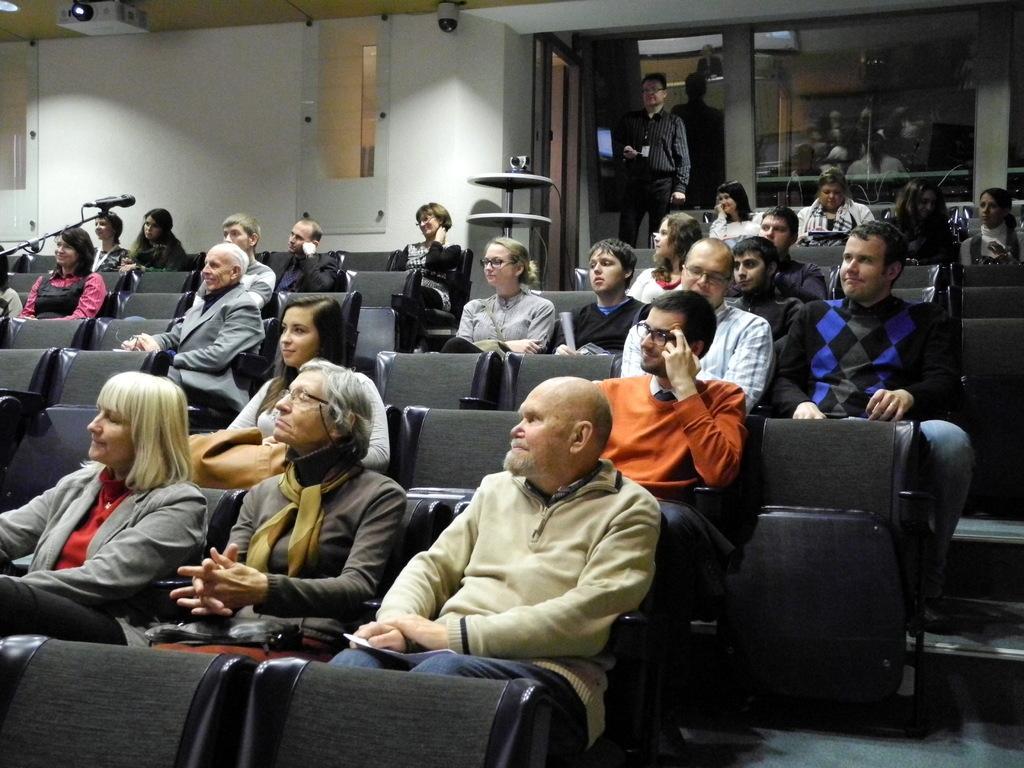Can you describe this image briefly? In this picture we can see a group of people and they are sitting on chairs and one person is standing and in the background we can see a mic, wall and some objects. 